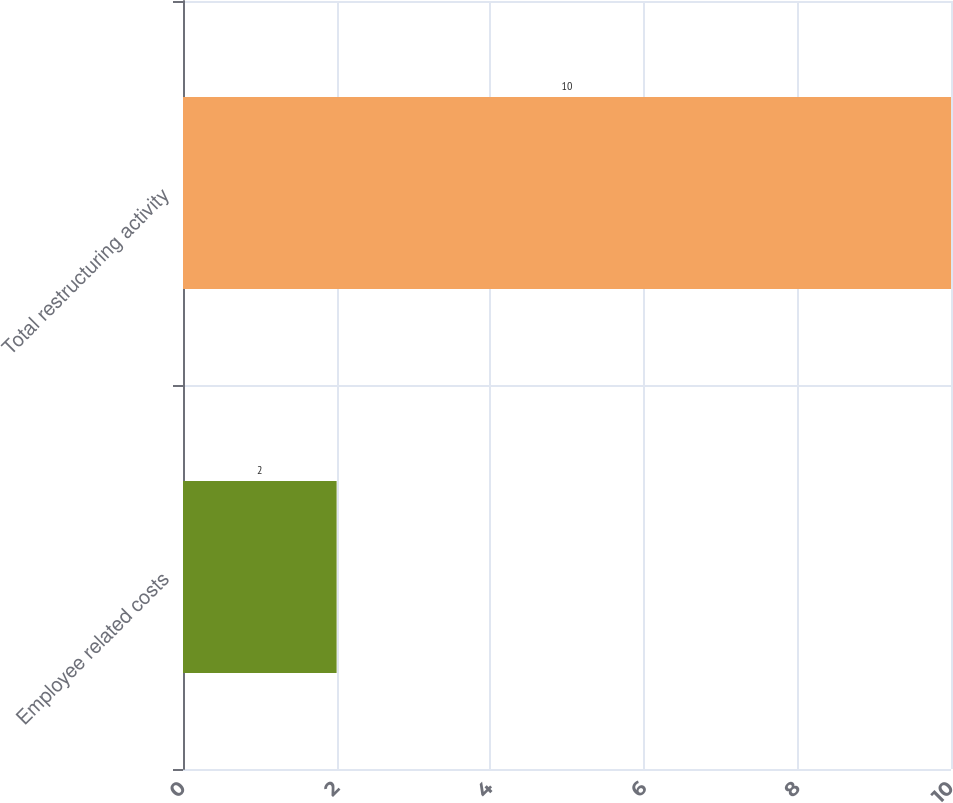Convert chart. <chart><loc_0><loc_0><loc_500><loc_500><bar_chart><fcel>Employee related costs<fcel>Total restructuring activity<nl><fcel>2<fcel>10<nl></chart> 